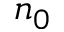Convert formula to latex. <formula><loc_0><loc_0><loc_500><loc_500>n _ { 0 }</formula> 